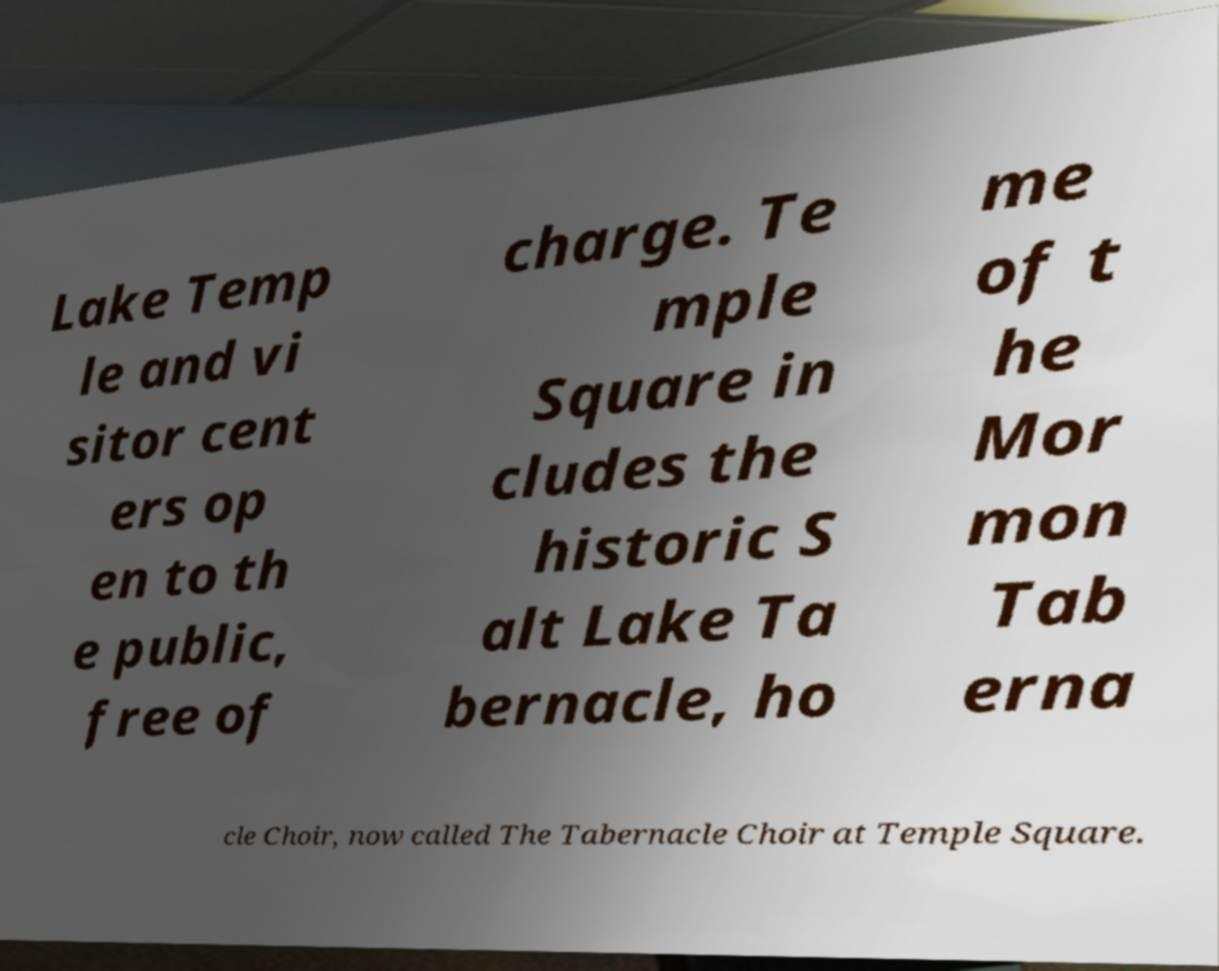What messages or text are displayed in this image? I need them in a readable, typed format. Lake Temp le and vi sitor cent ers op en to th e public, free of charge. Te mple Square in cludes the historic S alt Lake Ta bernacle, ho me of t he Mor mon Tab erna cle Choir, now called The Tabernacle Choir at Temple Square. 